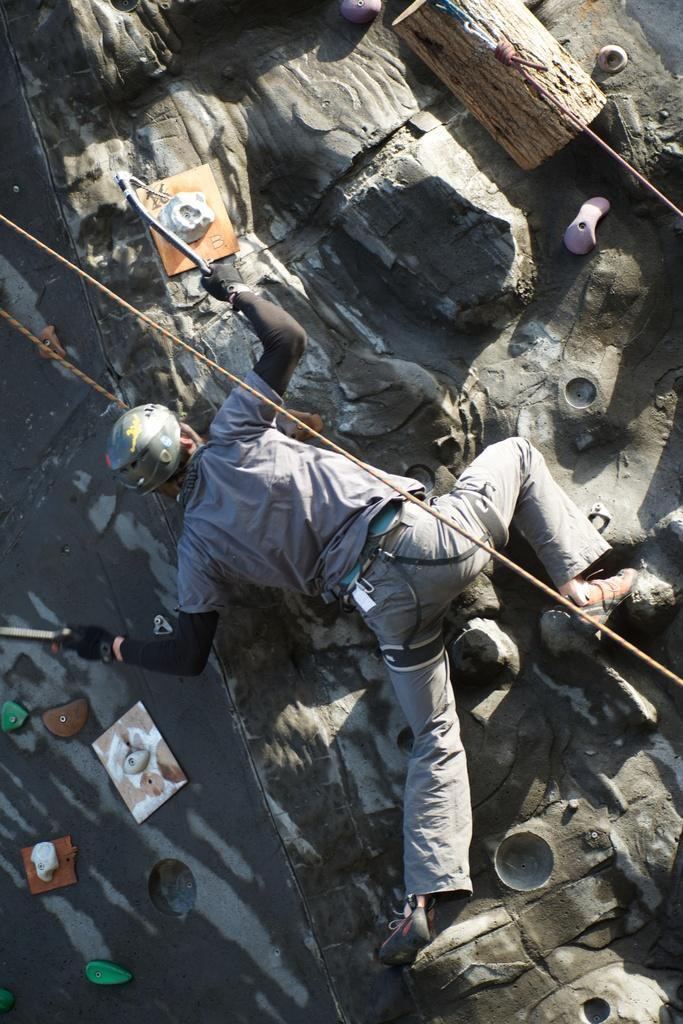Can you describe this image briefly? In this image there is a person climbing. 